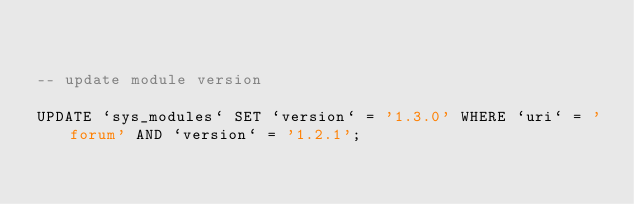Convert code to text. <code><loc_0><loc_0><loc_500><loc_500><_SQL_>

-- update module version

UPDATE `sys_modules` SET `version` = '1.3.0' WHERE `uri` = 'forum' AND `version` = '1.2.1';

</code> 